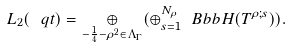Convert formula to latex. <formula><loc_0><loc_0><loc_500><loc_500>L _ { 2 } ( \ q t ) = \underset { - \frac { 1 } { 4 } - \rho ^ { 2 } \in \Lambda _ { \Gamma } } { \oplus } ( \oplus _ { s = 1 } ^ { N _ { \rho } } \ B b b { H } ( T ^ { \rho ; s } ) ) .</formula> 